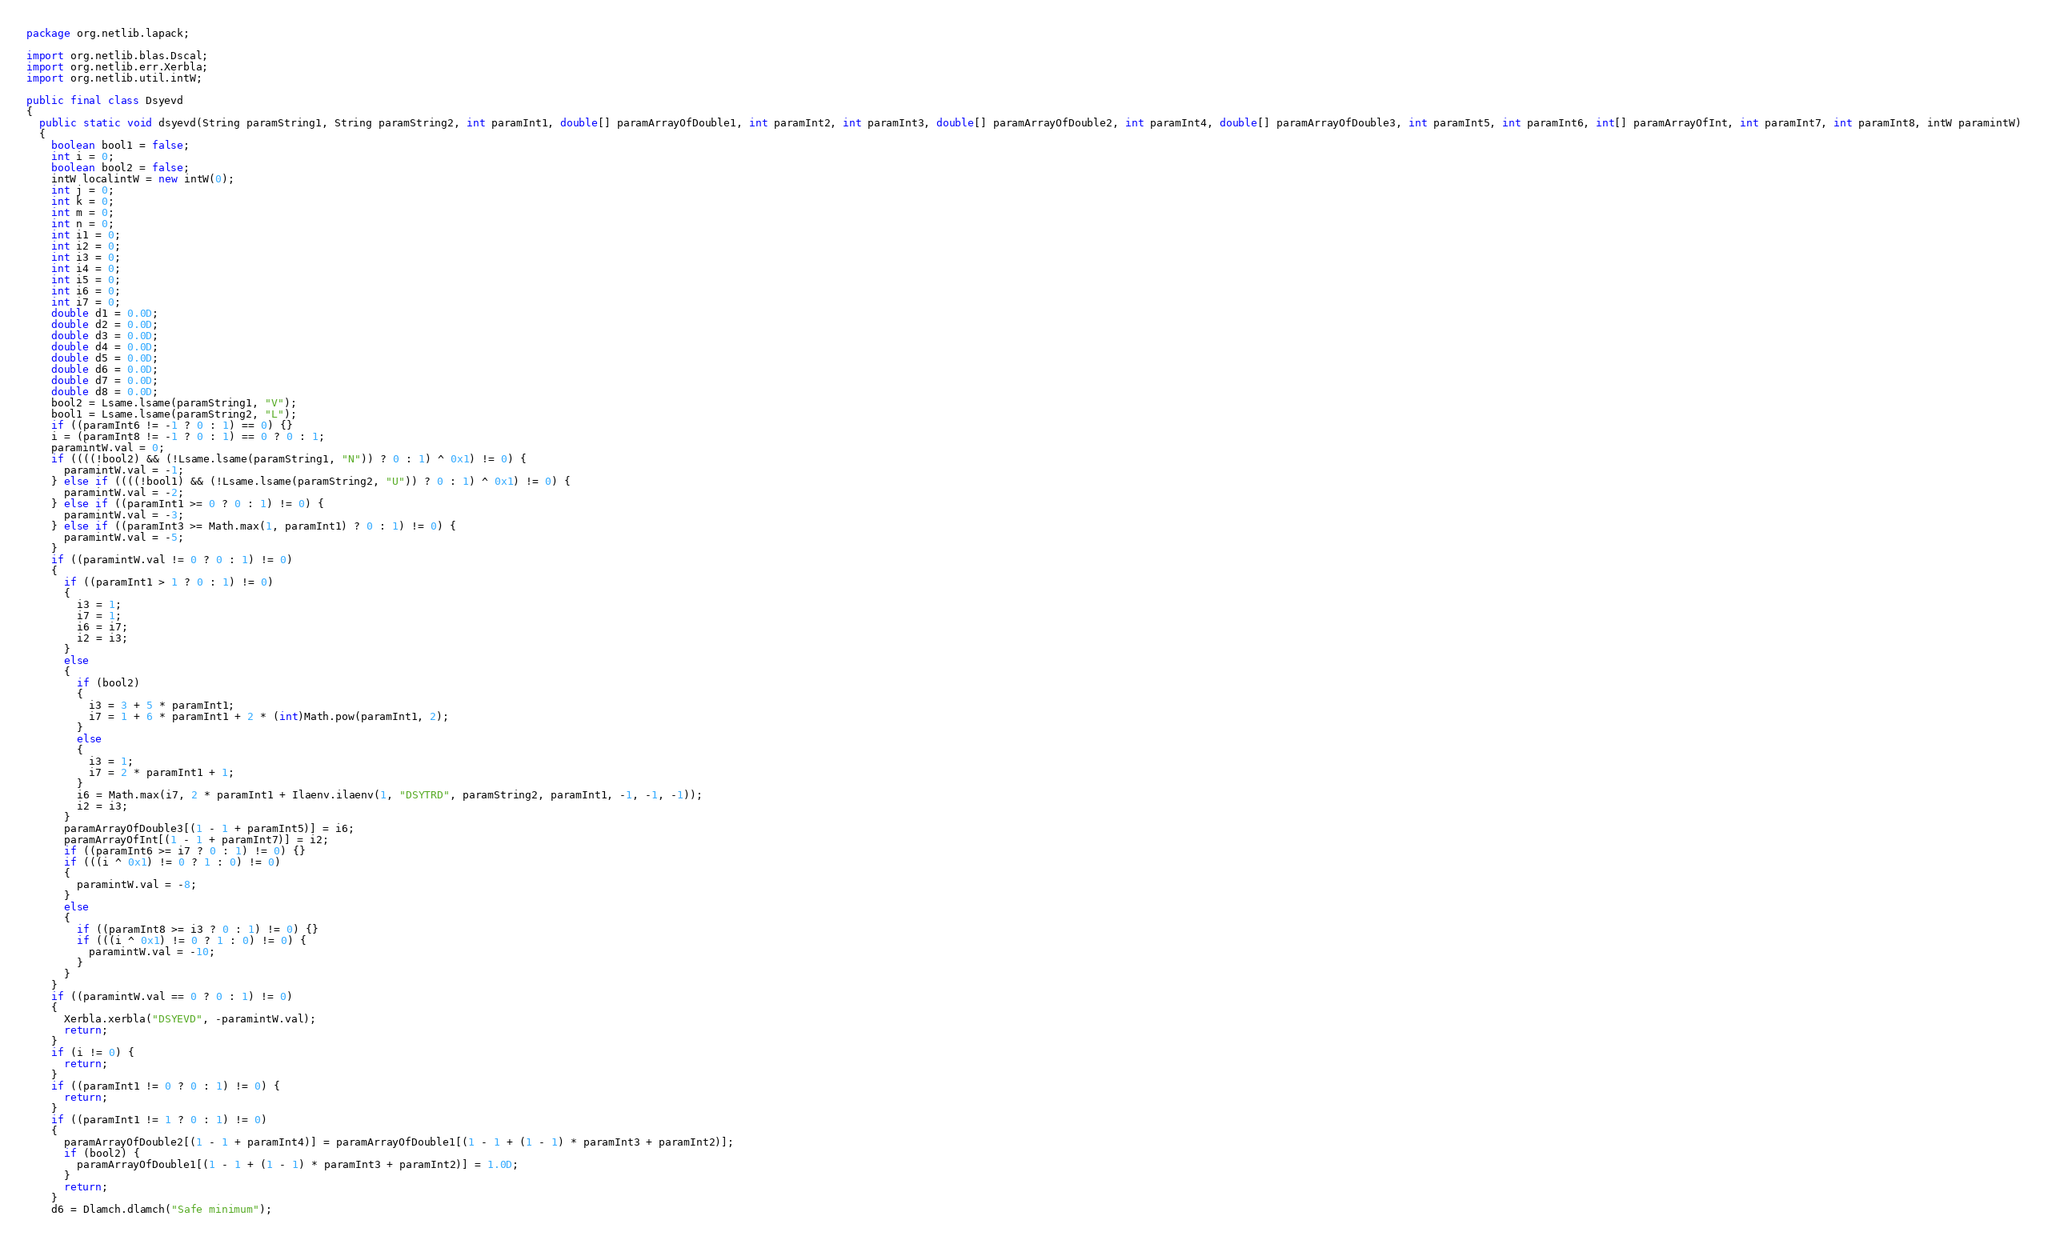Convert code to text. <code><loc_0><loc_0><loc_500><loc_500><_Java_>package org.netlib.lapack;

import org.netlib.blas.Dscal;
import org.netlib.err.Xerbla;
import org.netlib.util.intW;

public final class Dsyevd
{
  public static void dsyevd(String paramString1, String paramString2, int paramInt1, double[] paramArrayOfDouble1, int paramInt2, int paramInt3, double[] paramArrayOfDouble2, int paramInt4, double[] paramArrayOfDouble3, int paramInt5, int paramInt6, int[] paramArrayOfInt, int paramInt7, int paramInt8, intW paramintW)
  {
    boolean bool1 = false;
    int i = 0;
    boolean bool2 = false;
    intW localintW = new intW(0);
    int j = 0;
    int k = 0;
    int m = 0;
    int n = 0;
    int i1 = 0;
    int i2 = 0;
    int i3 = 0;
    int i4 = 0;
    int i5 = 0;
    int i6 = 0;
    int i7 = 0;
    double d1 = 0.0D;
    double d2 = 0.0D;
    double d3 = 0.0D;
    double d4 = 0.0D;
    double d5 = 0.0D;
    double d6 = 0.0D;
    double d7 = 0.0D;
    double d8 = 0.0D;
    bool2 = Lsame.lsame(paramString1, "V");
    bool1 = Lsame.lsame(paramString2, "L");
    if ((paramInt6 != -1 ? 0 : 1) == 0) {}
    i = (paramInt8 != -1 ? 0 : 1) == 0 ? 0 : 1;
    paramintW.val = 0;
    if ((((!bool2) && (!Lsame.lsame(paramString1, "N")) ? 0 : 1) ^ 0x1) != 0) {
      paramintW.val = -1;
    } else if ((((!bool1) && (!Lsame.lsame(paramString2, "U")) ? 0 : 1) ^ 0x1) != 0) {
      paramintW.val = -2;
    } else if ((paramInt1 >= 0 ? 0 : 1) != 0) {
      paramintW.val = -3;
    } else if ((paramInt3 >= Math.max(1, paramInt1) ? 0 : 1) != 0) {
      paramintW.val = -5;
    }
    if ((paramintW.val != 0 ? 0 : 1) != 0)
    {
      if ((paramInt1 > 1 ? 0 : 1) != 0)
      {
        i3 = 1;
        i7 = 1;
        i6 = i7;
        i2 = i3;
      }
      else
      {
        if (bool2)
        {
          i3 = 3 + 5 * paramInt1;
          i7 = 1 + 6 * paramInt1 + 2 * (int)Math.pow(paramInt1, 2);
        }
        else
        {
          i3 = 1;
          i7 = 2 * paramInt1 + 1;
        }
        i6 = Math.max(i7, 2 * paramInt1 + Ilaenv.ilaenv(1, "DSYTRD", paramString2, paramInt1, -1, -1, -1));
        i2 = i3;
      }
      paramArrayOfDouble3[(1 - 1 + paramInt5)] = i6;
      paramArrayOfInt[(1 - 1 + paramInt7)] = i2;
      if ((paramInt6 >= i7 ? 0 : 1) != 0) {}
      if (((i ^ 0x1) != 0 ? 1 : 0) != 0)
      {
        paramintW.val = -8;
      }
      else
      {
        if ((paramInt8 >= i3 ? 0 : 1) != 0) {}
        if (((i ^ 0x1) != 0 ? 1 : 0) != 0) {
          paramintW.val = -10;
        }
      }
    }
    if ((paramintW.val == 0 ? 0 : 1) != 0)
    {
      Xerbla.xerbla("DSYEVD", -paramintW.val);
      return;
    }
    if (i != 0) {
      return;
    }
    if ((paramInt1 != 0 ? 0 : 1) != 0) {
      return;
    }
    if ((paramInt1 != 1 ? 0 : 1) != 0)
    {
      paramArrayOfDouble2[(1 - 1 + paramInt4)] = paramArrayOfDouble1[(1 - 1 + (1 - 1) * paramInt3 + paramInt2)];
      if (bool2) {
        paramArrayOfDouble1[(1 - 1 + (1 - 1) * paramInt3 + paramInt2)] = 1.0D;
      }
      return;
    }
    d6 = Dlamch.dlamch("Safe minimum");</code> 